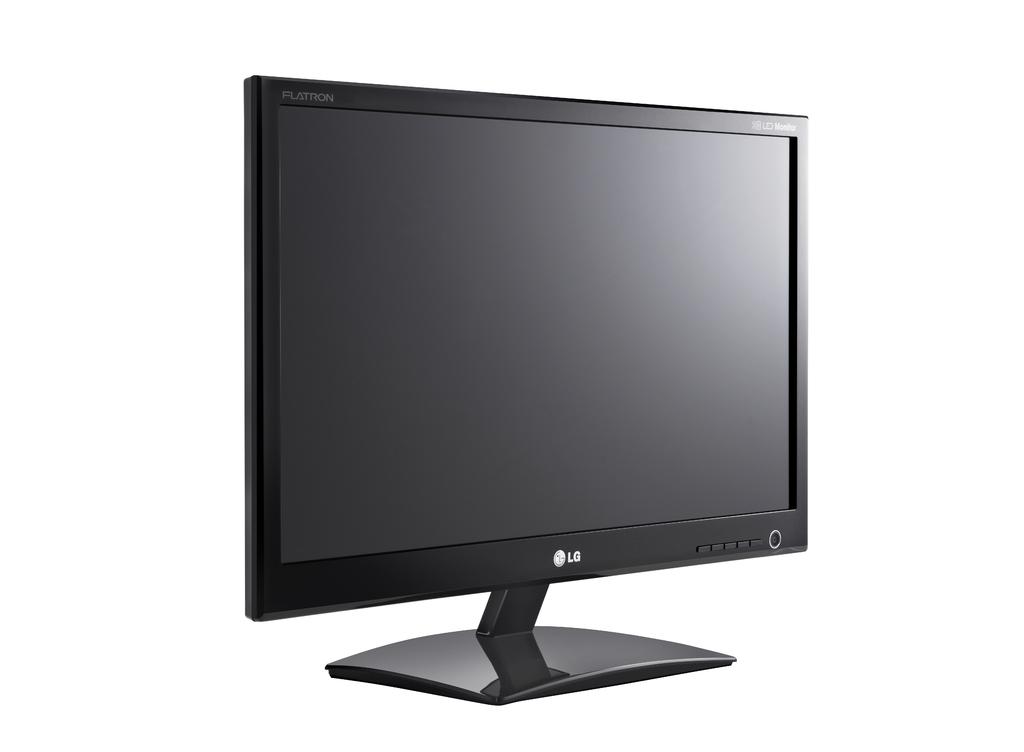What brand is this monitor?
Keep it short and to the point. Lg. Is this an led monitor?
Your answer should be very brief. Yes. 